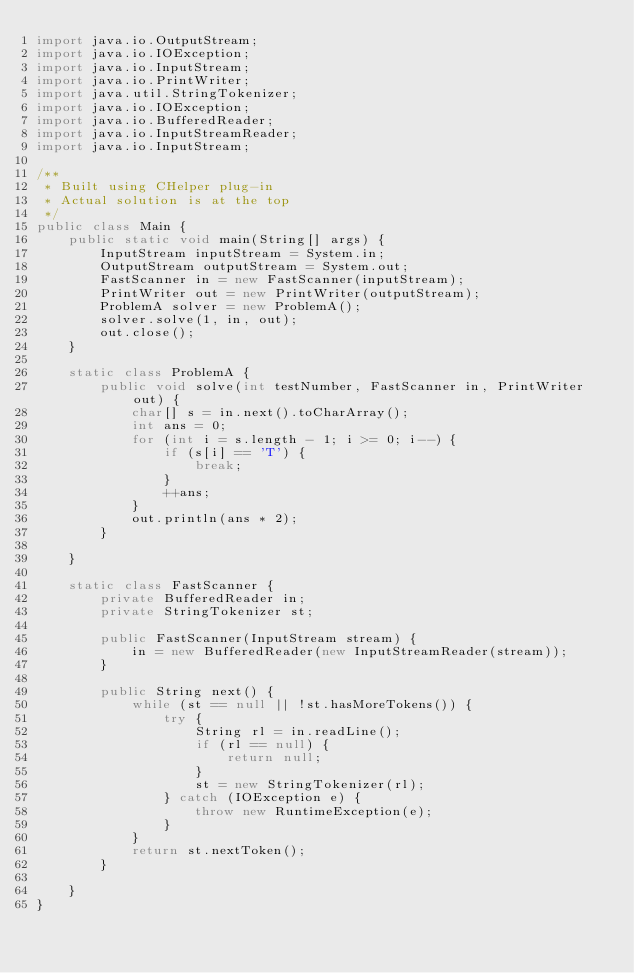Convert code to text. <code><loc_0><loc_0><loc_500><loc_500><_Java_>import java.io.OutputStream;
import java.io.IOException;
import java.io.InputStream;
import java.io.PrintWriter;
import java.util.StringTokenizer;
import java.io.IOException;
import java.io.BufferedReader;
import java.io.InputStreamReader;
import java.io.InputStream;

/**
 * Built using CHelper plug-in
 * Actual solution is at the top
 */
public class Main {
	public static void main(String[] args) {
		InputStream inputStream = System.in;
		OutputStream outputStream = System.out;
		FastScanner in = new FastScanner(inputStream);
		PrintWriter out = new PrintWriter(outputStream);
		ProblemA solver = new ProblemA();
		solver.solve(1, in, out);
		out.close();
	}

	static class ProblemA {
		public void solve(int testNumber, FastScanner in, PrintWriter out) {
			char[] s = in.next().toCharArray();
			int ans = 0;
			for (int i = s.length - 1; i >= 0; i--) {
				if (s[i] == 'T') {
					break;
				}
				++ans;
			}
			out.println(ans * 2);
		}

	}

	static class FastScanner {
		private BufferedReader in;
		private StringTokenizer st;

		public FastScanner(InputStream stream) {
			in = new BufferedReader(new InputStreamReader(stream));
		}

		public String next() {
			while (st == null || !st.hasMoreTokens()) {
				try {
					String rl = in.readLine();
					if (rl == null) {
						return null;
					}
					st = new StringTokenizer(rl);
				} catch (IOException e) {
					throw new RuntimeException(e);
				}
			}
			return st.nextToken();
		}

	}
}

</code> 